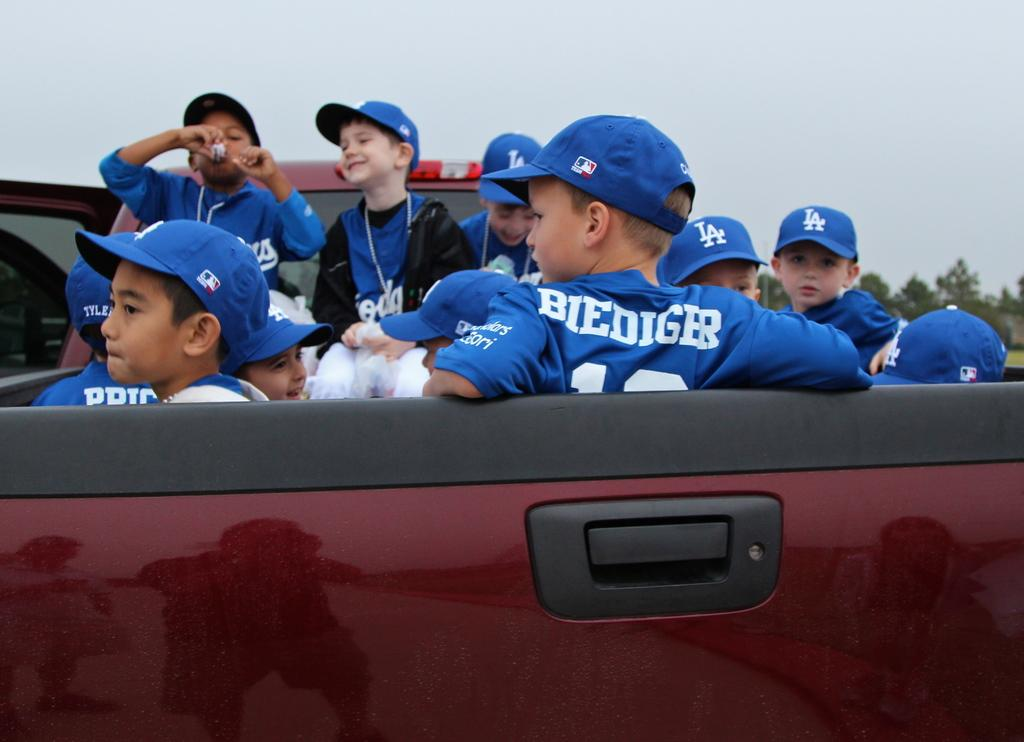Provide a one-sentence caption for the provided image. Kids sitting in the back of a truck, one of them is named Biediger. 